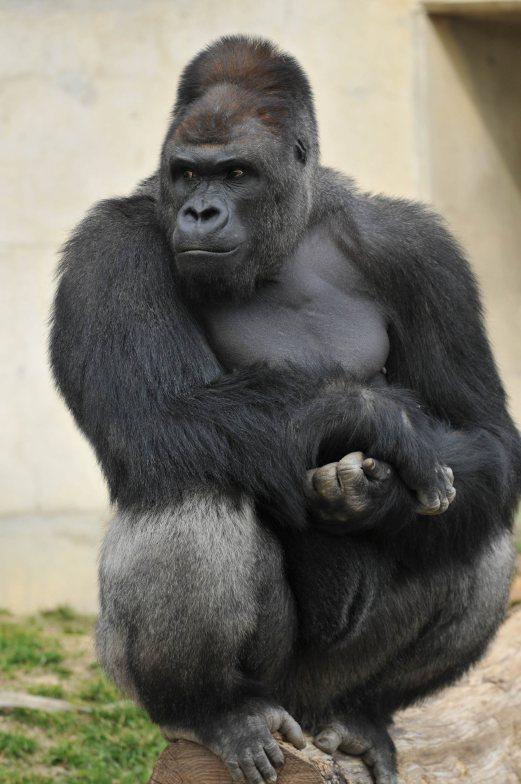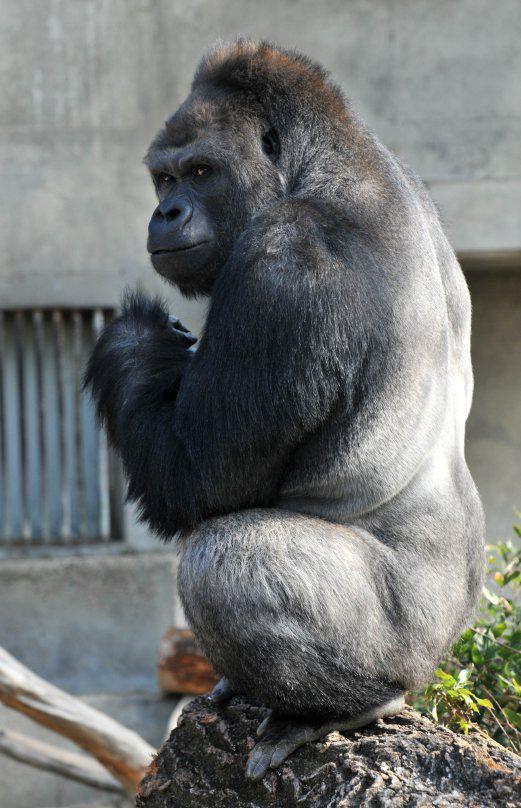The first image is the image on the left, the second image is the image on the right. Examine the images to the left and right. Is the description "An image shows a young gorilla close to an adult gorilla." accurate? Answer yes or no. No. The first image is the image on the left, the second image is the image on the right. Analyze the images presented: Is the assertion "There are 2 seated gorillas." valid? Answer yes or no. Yes. 